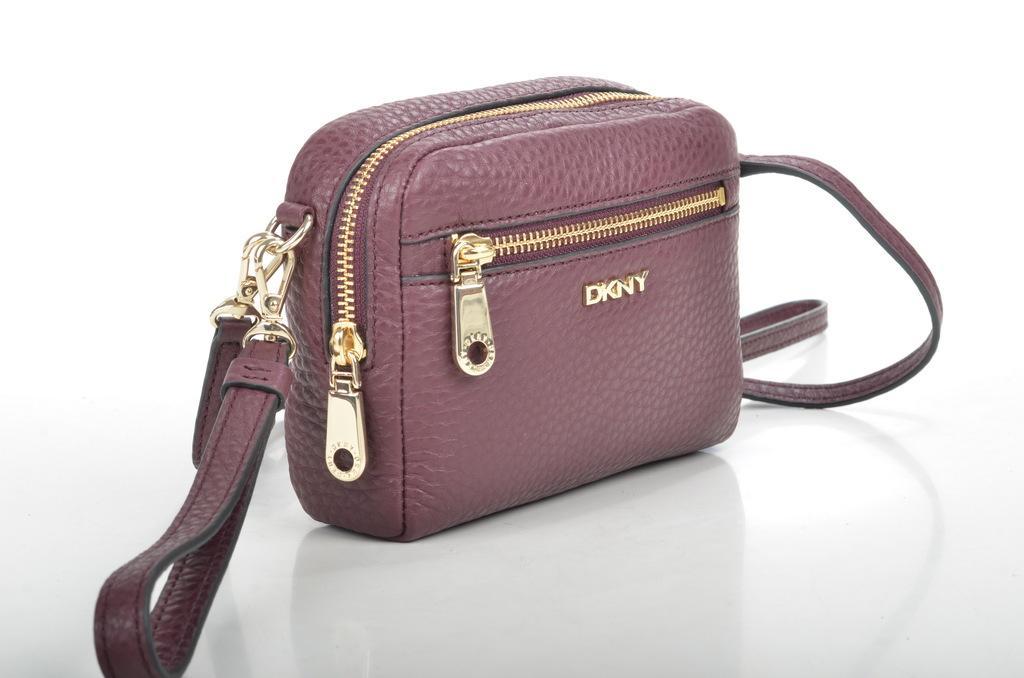Can you describe this image briefly? there is a bag which has 2 zips. on the bag dkny is written. it is a small bag placed on a white surface. 